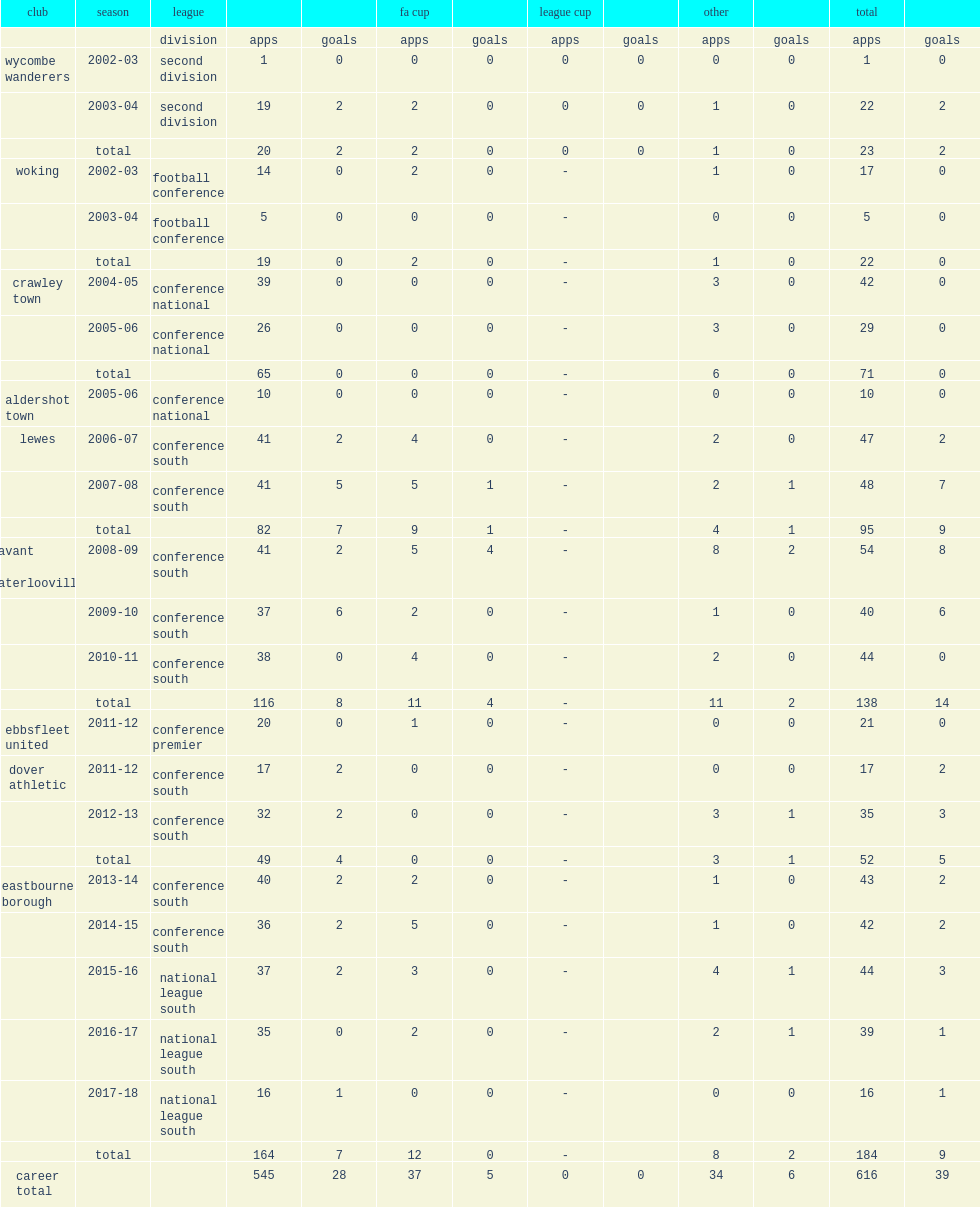Which club in the football league second division did simpemba play for both the 2002-03 and 2003-04 seasons? Wycombe wanderers. 